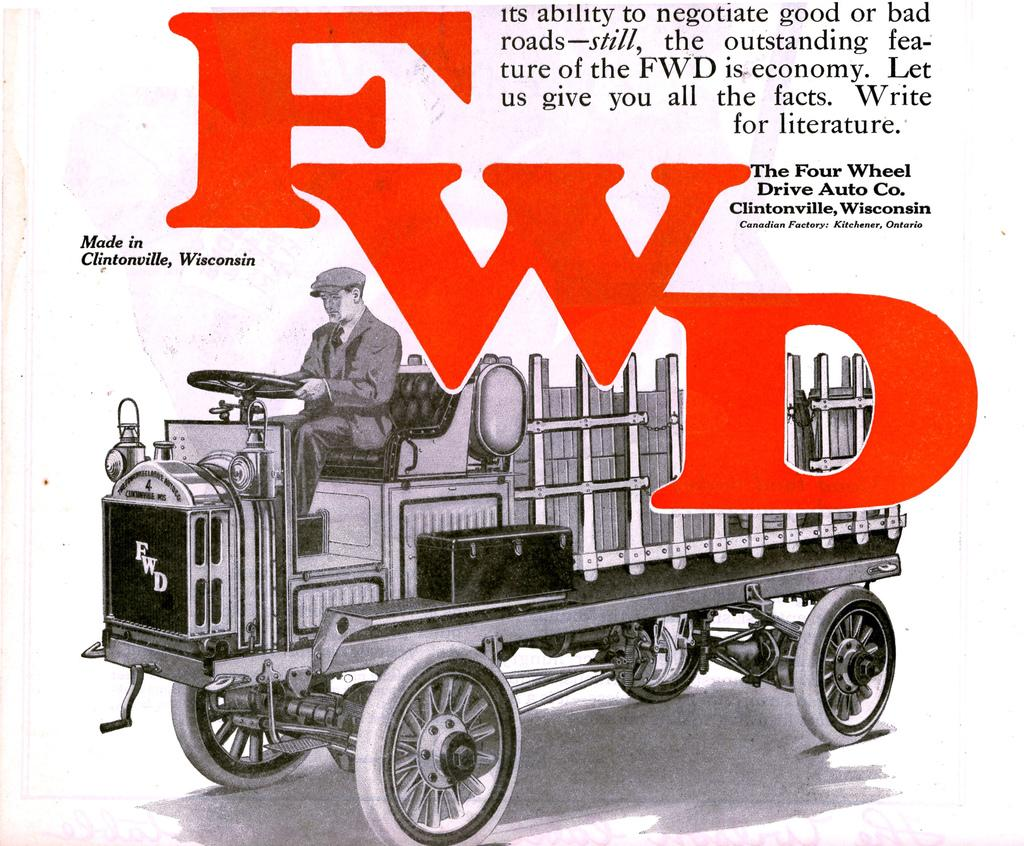What type of visual is the image? The image is a poster. What is featured on the poster? The poster contains a painting. What colors are used for the text on the poster? There are red color letters and black color texts on the poster. What is happening in the painting? The painting depicts a person driving a vehicle. What is the color of the background in the painting? The background of the painting is white in color. What sound does the queen make while playing chess on the board in the image? There is no queen, chessboard, or sound present in the image. The image features a painting of a person driving a vehicle with a white background. 